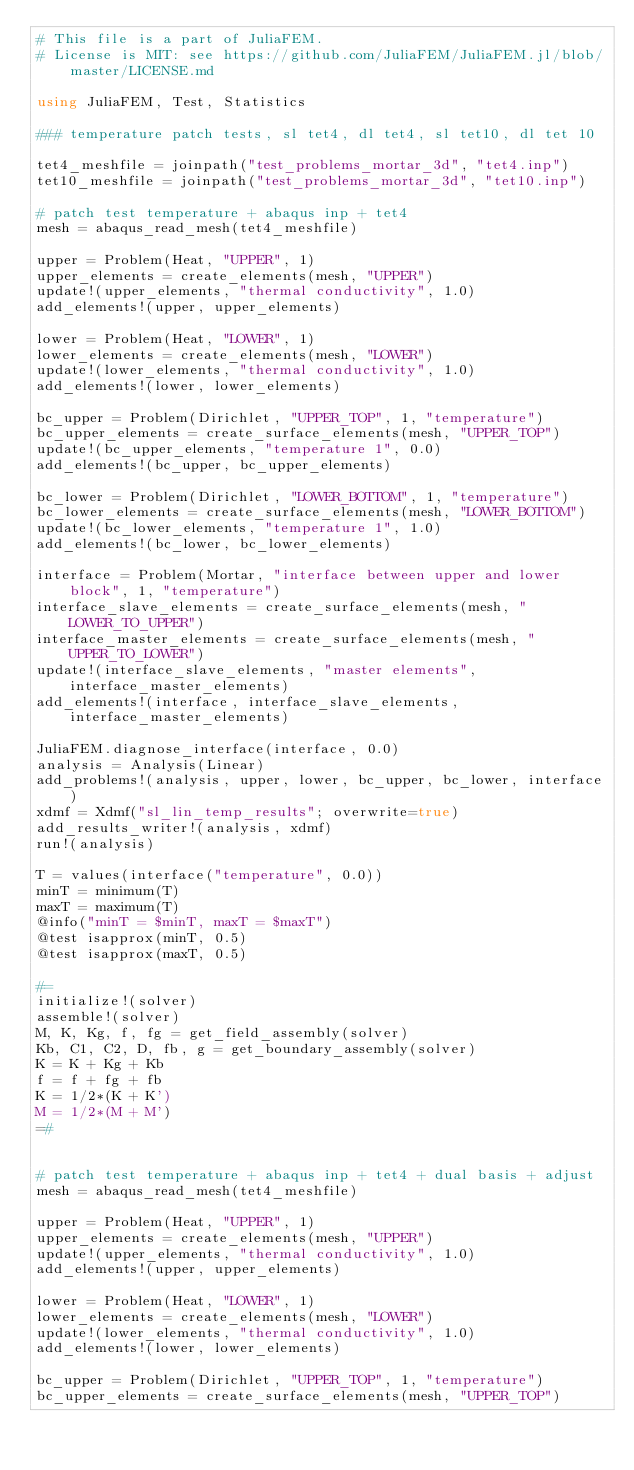<code> <loc_0><loc_0><loc_500><loc_500><_Julia_># This file is a part of JuliaFEM.
# License is MIT: see https://github.com/JuliaFEM/JuliaFEM.jl/blob/master/LICENSE.md

using JuliaFEM, Test, Statistics

### temperature patch tests, sl tet4, dl tet4, sl tet10, dl tet 10

tet4_meshfile = joinpath("test_problems_mortar_3d", "tet4.inp")
tet10_meshfile = joinpath("test_problems_mortar_3d", "tet10.inp")

# patch test temperature + abaqus inp + tet4
mesh = abaqus_read_mesh(tet4_meshfile)

upper = Problem(Heat, "UPPER", 1)
upper_elements = create_elements(mesh, "UPPER")
update!(upper_elements, "thermal conductivity", 1.0)
add_elements!(upper, upper_elements)

lower = Problem(Heat, "LOWER", 1)
lower_elements = create_elements(mesh, "LOWER")
update!(lower_elements, "thermal conductivity", 1.0)
add_elements!(lower, lower_elements)

bc_upper = Problem(Dirichlet, "UPPER_TOP", 1, "temperature")
bc_upper_elements = create_surface_elements(mesh, "UPPER_TOP")
update!(bc_upper_elements, "temperature 1", 0.0)
add_elements!(bc_upper, bc_upper_elements)

bc_lower = Problem(Dirichlet, "LOWER_BOTTOM", 1, "temperature")
bc_lower_elements = create_surface_elements(mesh, "LOWER_BOTTOM")
update!(bc_lower_elements, "temperature 1", 1.0)
add_elements!(bc_lower, bc_lower_elements)

interface = Problem(Mortar, "interface between upper and lower block", 1, "temperature")
interface_slave_elements = create_surface_elements(mesh, "LOWER_TO_UPPER")
interface_master_elements = create_surface_elements(mesh, "UPPER_TO_LOWER")
update!(interface_slave_elements, "master elements", interface_master_elements)
add_elements!(interface, interface_slave_elements, interface_master_elements)

JuliaFEM.diagnose_interface(interface, 0.0)
analysis = Analysis(Linear)
add_problems!(analysis, upper, lower, bc_upper, bc_lower, interface)
xdmf = Xdmf("sl_lin_temp_results"; overwrite=true)
add_results_writer!(analysis, xdmf)
run!(analysis)

T = values(interface("temperature", 0.0))
minT = minimum(T)
maxT = maximum(T)
@info("minT = $minT, maxT = $maxT")
@test isapprox(minT, 0.5)
@test isapprox(maxT, 0.5)

#=
initialize!(solver)
assemble!(solver)
M, K, Kg, f, fg = get_field_assembly(solver)
Kb, C1, C2, D, fb, g = get_boundary_assembly(solver)
K = K + Kg + Kb
f = f + fg + fb
K = 1/2*(K + K')
M = 1/2*(M + M')
=#


# patch test temperature + abaqus inp + tet4 + dual basis + adjust
mesh = abaqus_read_mesh(tet4_meshfile)

upper = Problem(Heat, "UPPER", 1)
upper_elements = create_elements(mesh, "UPPER")
update!(upper_elements, "thermal conductivity", 1.0)
add_elements!(upper, upper_elements)

lower = Problem(Heat, "LOWER", 1)
lower_elements = create_elements(mesh, "LOWER")
update!(lower_elements, "thermal conductivity", 1.0)
add_elements!(lower, lower_elements)

bc_upper = Problem(Dirichlet, "UPPER_TOP", 1, "temperature")
bc_upper_elements = create_surface_elements(mesh, "UPPER_TOP")</code> 